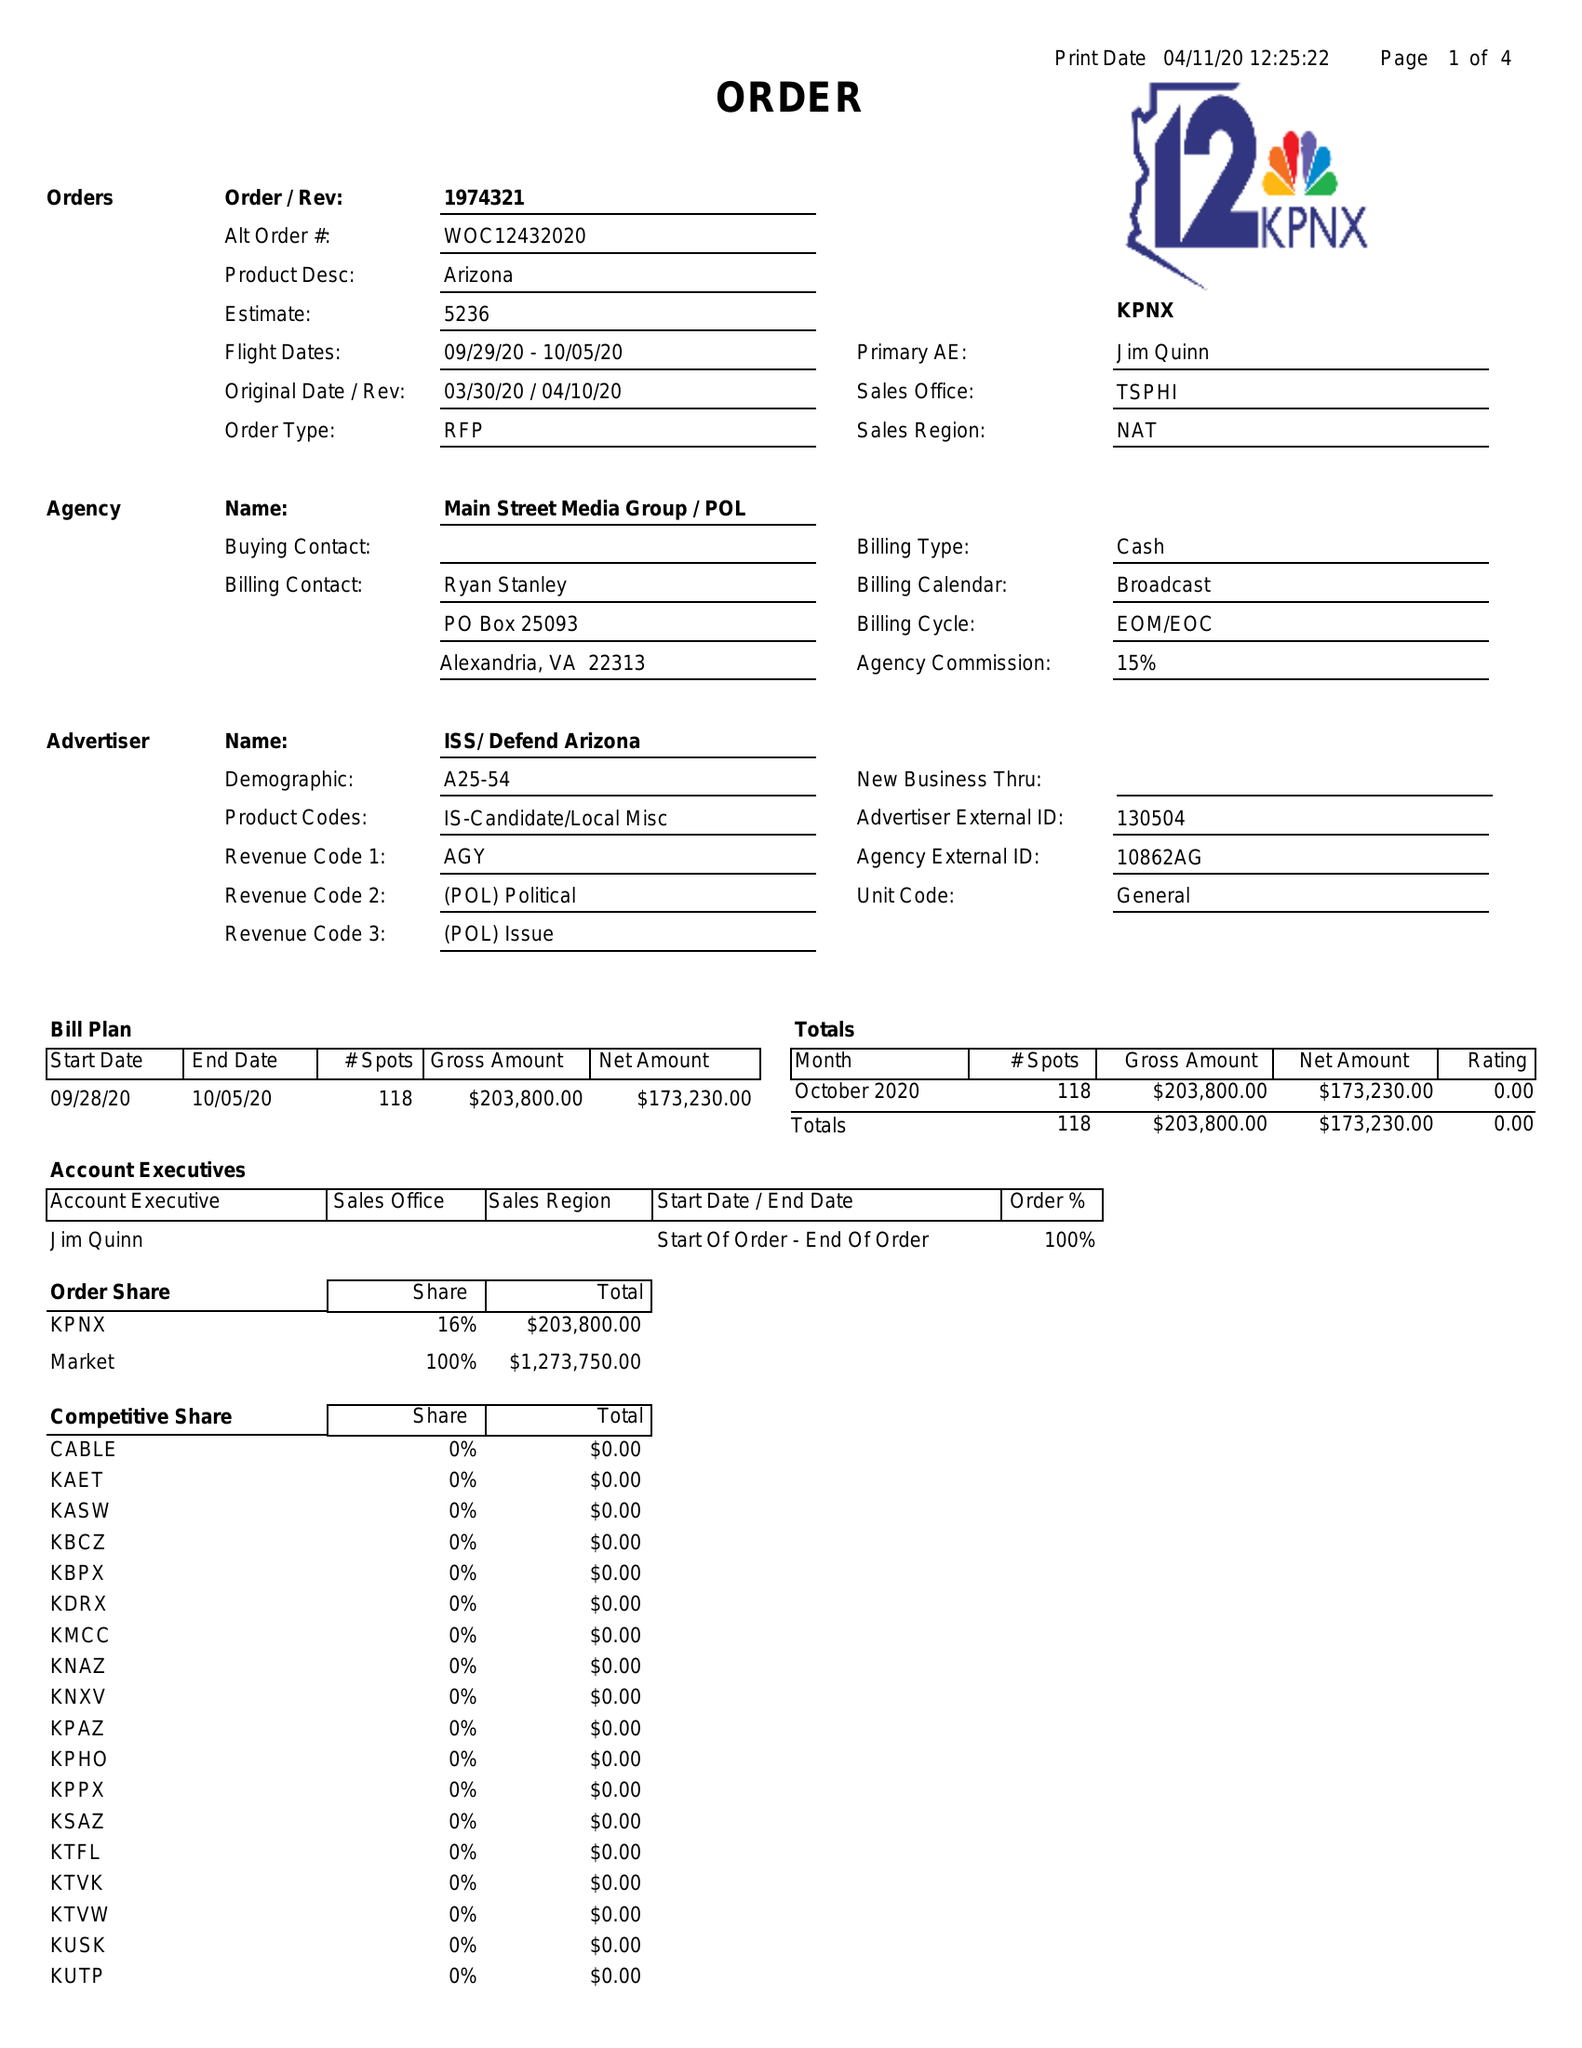What is the value for the flight_to?
Answer the question using a single word or phrase. 10/05/20 